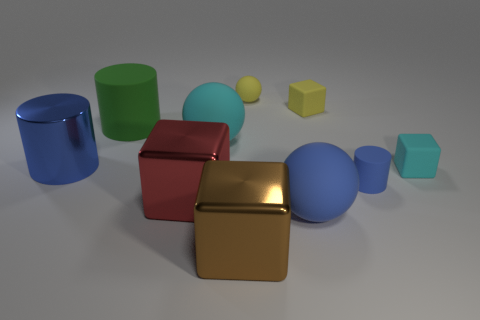What number of other big cubes have the same material as the big brown cube?
Make the answer very short. 1. What number of matte things are brown objects or big balls?
Provide a succinct answer. 2. There is a brown cube that is the same size as the metallic cylinder; what is its material?
Offer a terse response. Metal. Are there any small yellow objects made of the same material as the blue sphere?
Your response must be concise. Yes. What shape is the blue thing behind the small blue matte thing in front of the big rubber ball that is behind the cyan matte cube?
Provide a succinct answer. Cylinder. Does the blue rubber ball have the same size as the yellow rubber ball that is behind the red block?
Offer a very short reply. No. There is a thing that is both left of the large red shiny object and behind the big metal cylinder; what shape is it?
Provide a succinct answer. Cylinder. What number of small things are either brown things or brown balls?
Ensure brevity in your answer.  0. Are there an equal number of large blue metal cylinders in front of the large cyan thing and big balls that are to the right of the large brown thing?
Give a very brief answer. Yes. How many other objects are the same color as the small cylinder?
Keep it short and to the point. 2. 